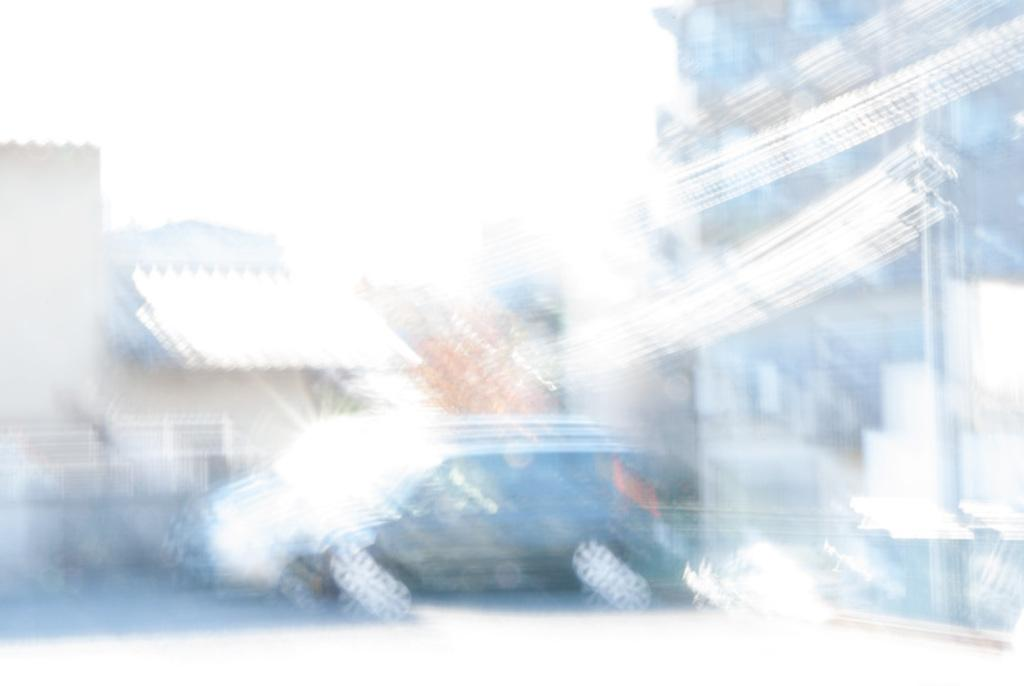What type of vehicles can be seen in the image? There are cars in the image. What type of structures are present in the image? There are buildings in the image. What type of cave can be seen in the image? There is no cave present in the image; it features cars and buildings. What type of prose is being written in the image? There is no writing or prose present in the image. 